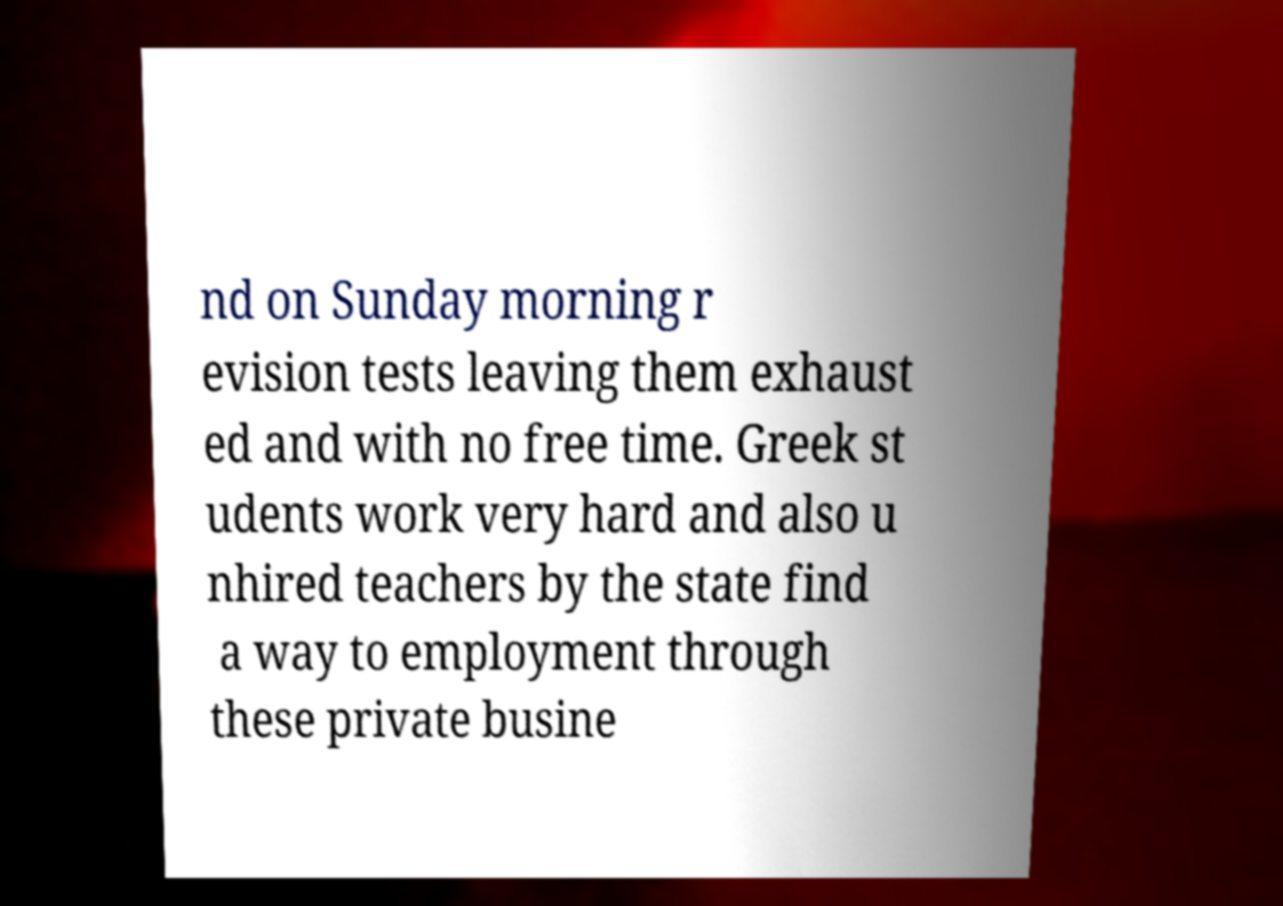Please identify and transcribe the text found in this image. nd on Sunday morning r evision tests leaving them exhaust ed and with no free time. Greek st udents work very hard and also u nhired teachers by the state find a way to employment through these private busine 